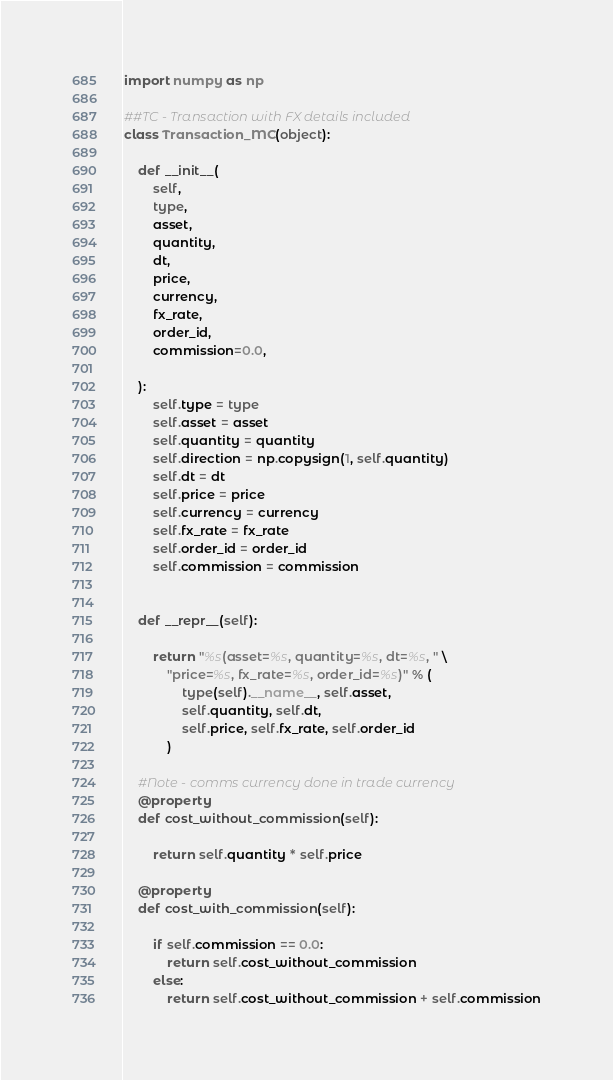<code> <loc_0><loc_0><loc_500><loc_500><_Python_>import numpy as np

##TC - Transaction with FX details included
class Transaction_MC(object):

    def __init__(
        self,
        type,
        asset,
        quantity,
        dt,
        price,
        currency,
        fx_rate,
        order_id,
        commission=0.0,
        
    ):
        self.type = type
        self.asset = asset
        self.quantity = quantity
        self.direction = np.copysign(1, self.quantity)
        self.dt = dt
        self.price = price
        self.currency = currency
        self.fx_rate = fx_rate
        self.order_id = order_id
        self.commission = commission
        

    def __repr__(self):

        return "%s(asset=%s, quantity=%s, dt=%s, " \
            "price=%s, fx_rate=%s, order_id=%s)" % (
                type(self).__name__, self.asset,
                self.quantity, self.dt,
                self.price, self.fx_rate, self.order_id
            )

    #Note - comms currency done in trade currency
    @property
    def cost_without_commission(self):

        return self.quantity * self.price

    @property
    def cost_with_commission(self):

        if self.commission == 0.0:
            return self.cost_without_commission
        else:
            return self.cost_without_commission + self.commission
</code> 